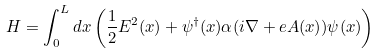<formula> <loc_0><loc_0><loc_500><loc_500>H = \int _ { 0 } ^ { L } d x \left ( { \frac { 1 } { 2 } } E ^ { 2 } ( x ) + \psi ^ { \dagger } ( x ) \alpha ( i \nabla + e A ( x ) ) \psi ( x ) \right )</formula> 